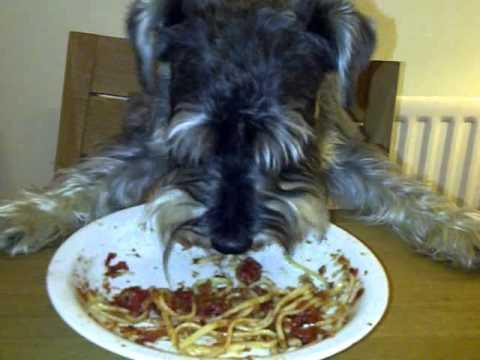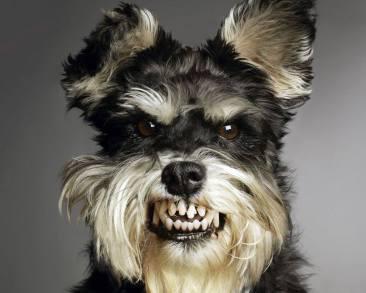The first image is the image on the left, the second image is the image on the right. Examine the images to the left and right. Is the description "One dog is eating and the other dog is not near food." accurate? Answer yes or no. Yes. 